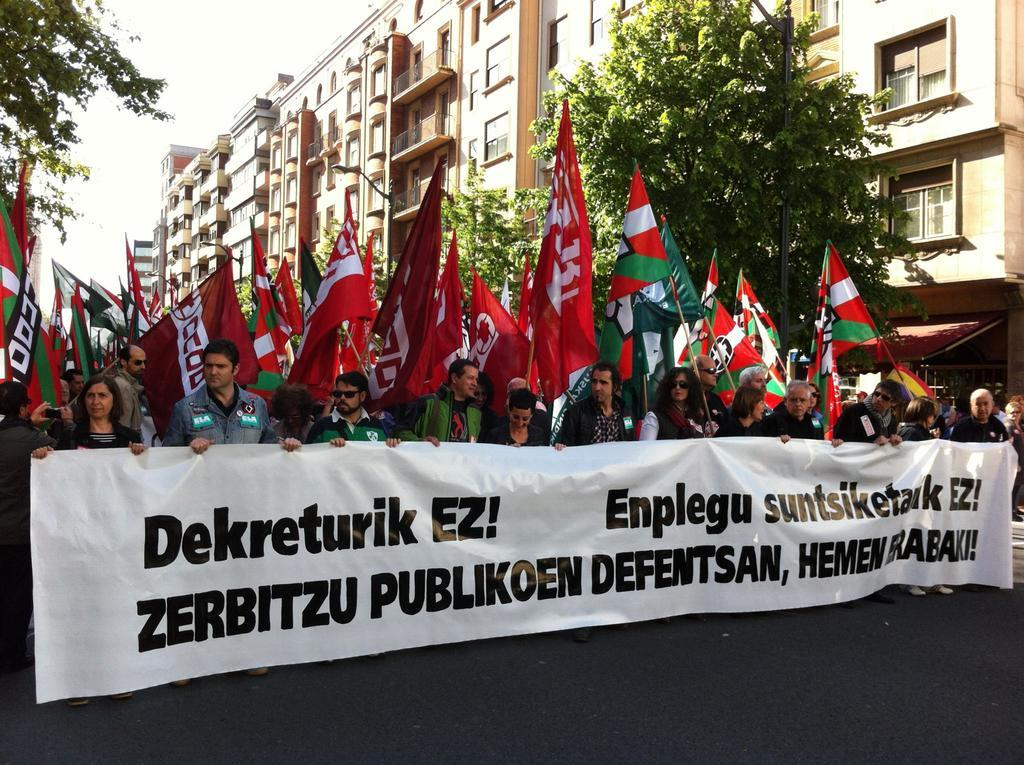How many people are in the image? There is a group of people in the image, but the exact number is not specified. What are some people holding in the image? Some people are holding a flex, while others are holding flags. What can be seen in the background of the image? There are trees and buildings in the background of the image. How many tents are set up in the image? There is no mention of tents in the image; it features a group of people holding a flex and flags, with trees and buildings in the background. 